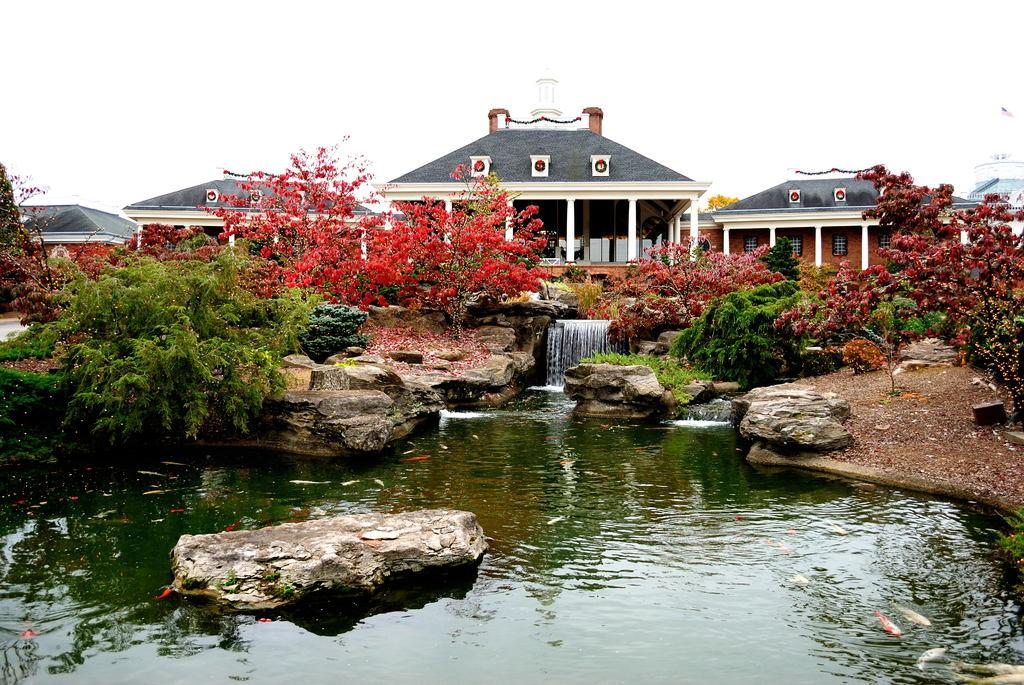What is located in the center of the image? There are plants, rocks, and water in the center of the image. What type of natural elements are present in the center of the image? Plants, rocks, and water are natural elements present in the center of the image. What can be seen in the background of the image? There is a building in the background of the image. What is visible at the top of the image? The sky is visible at the top of the image. Can you tell me how many volleyballs are on the rocks in the image? There are no volleyballs present in the image; it features plants, rocks, and water in the center. What type of trouble is the building facing in the image? There is no indication of any trouble or issue with the building in the image. 